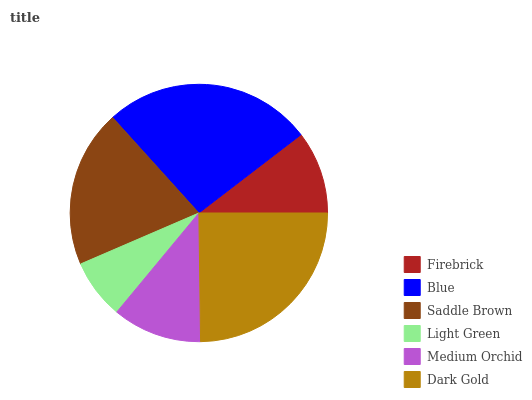Is Light Green the minimum?
Answer yes or no. Yes. Is Blue the maximum?
Answer yes or no. Yes. Is Saddle Brown the minimum?
Answer yes or no. No. Is Saddle Brown the maximum?
Answer yes or no. No. Is Blue greater than Saddle Brown?
Answer yes or no. Yes. Is Saddle Brown less than Blue?
Answer yes or no. Yes. Is Saddle Brown greater than Blue?
Answer yes or no. No. Is Blue less than Saddle Brown?
Answer yes or no. No. Is Saddle Brown the high median?
Answer yes or no. Yes. Is Medium Orchid the low median?
Answer yes or no. Yes. Is Dark Gold the high median?
Answer yes or no. No. Is Blue the low median?
Answer yes or no. No. 